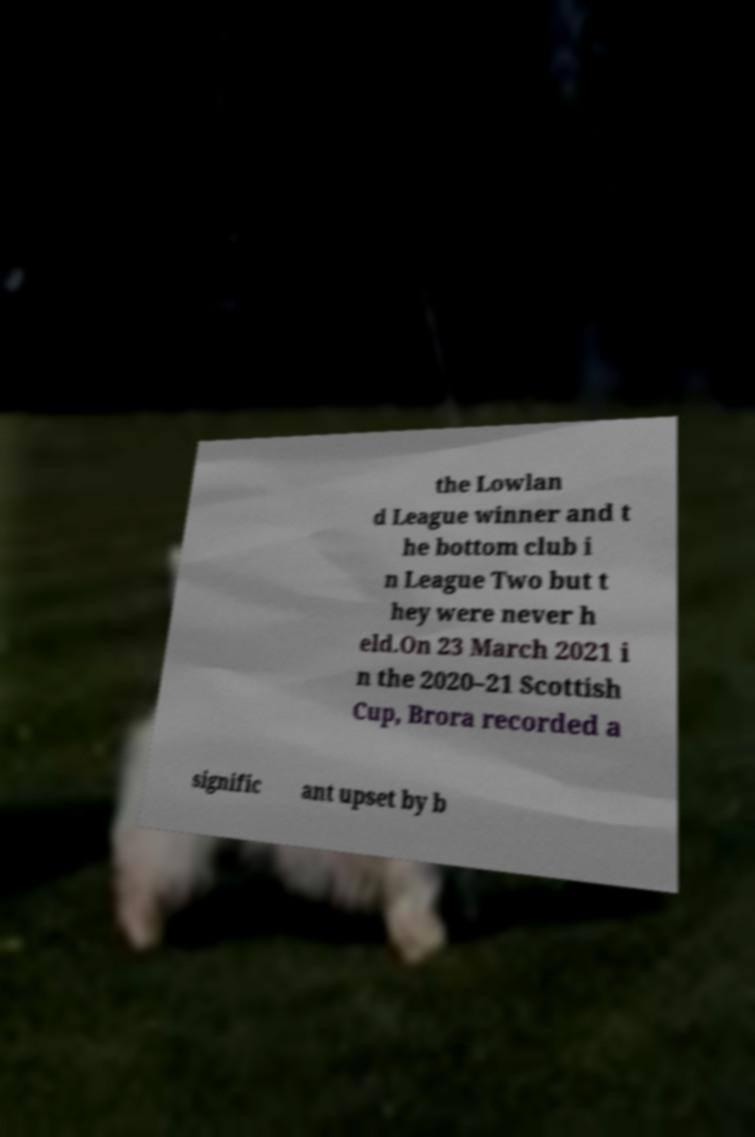Could you assist in decoding the text presented in this image and type it out clearly? the Lowlan d League winner and t he bottom club i n League Two but t hey were never h eld.On 23 March 2021 i n the 2020–21 Scottish Cup, Brora recorded a signific ant upset by b 